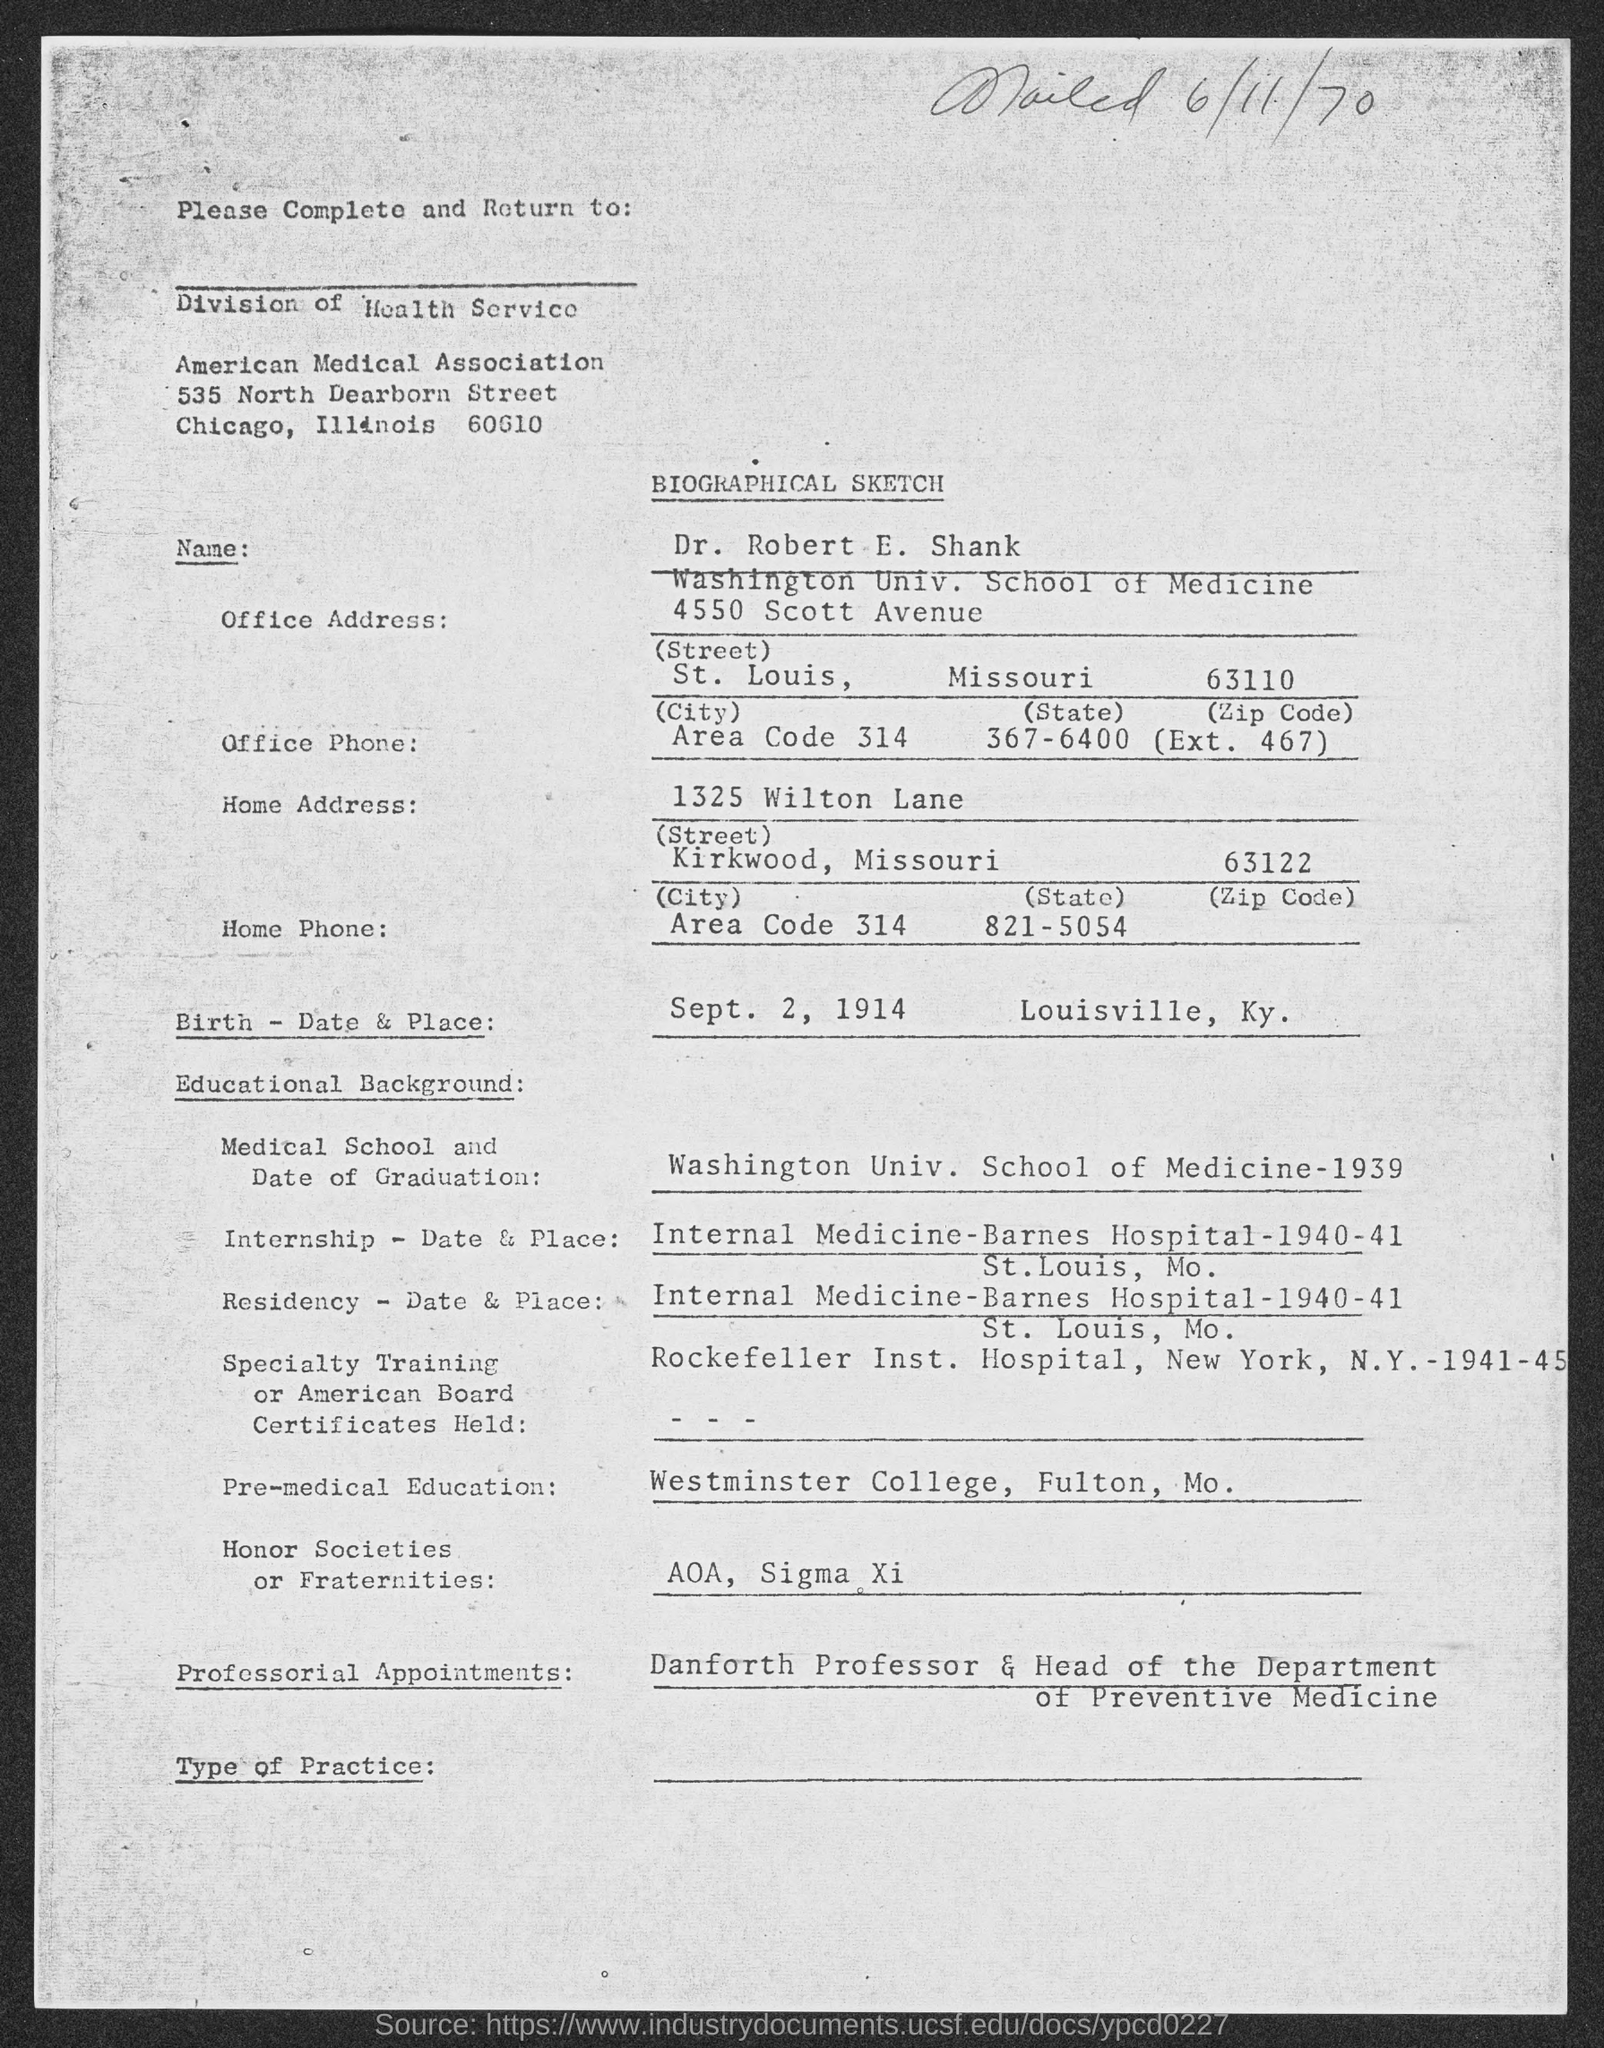Give some essential details in this illustration. The letter was mailed on June 11, 1970. The birthplace of Louisville, Kentucky is located in the city of Louisville. The name is Dr. Robert E. Shank. The birth date is September 2, 1914. 